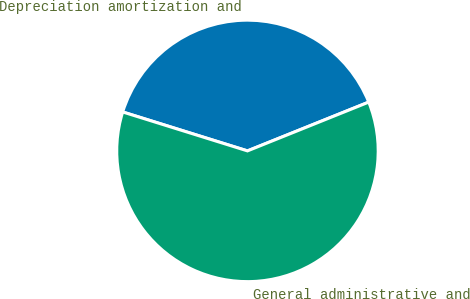<chart> <loc_0><loc_0><loc_500><loc_500><pie_chart><fcel>Depreciation amortization and<fcel>General administrative and<nl><fcel>39.1%<fcel>60.9%<nl></chart> 